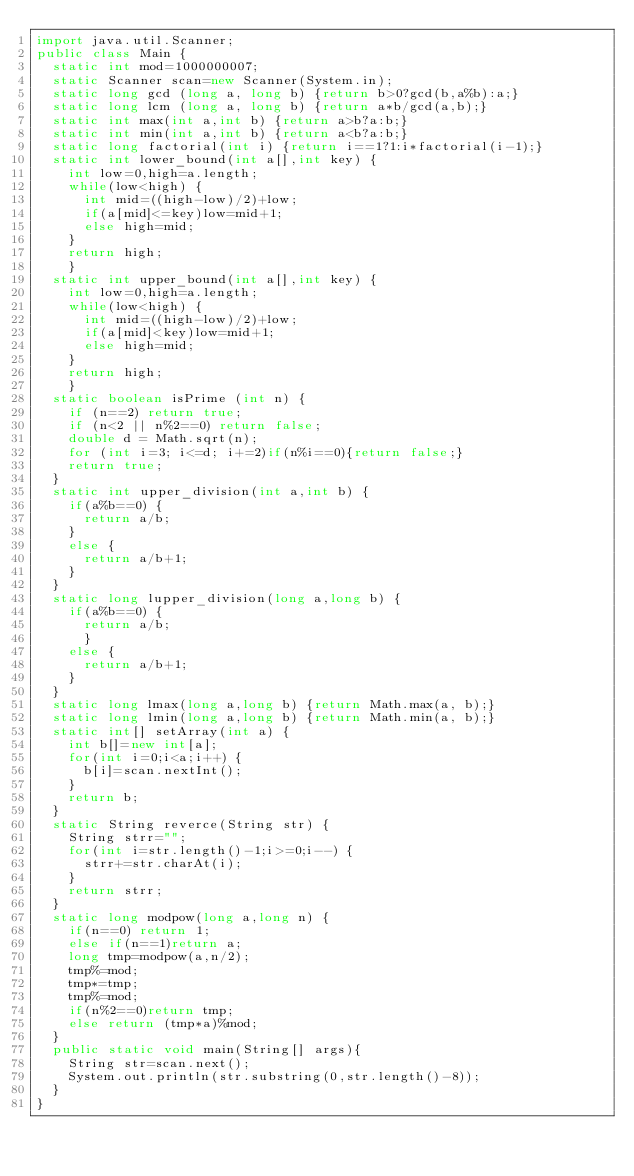Convert code to text. <code><loc_0><loc_0><loc_500><loc_500><_Java_>import java.util.Scanner;
public class Main {
	static int mod=1000000007;
	static Scanner scan=new Scanner(System.in);
	static long gcd (long a, long b) {return b>0?gcd(b,a%b):a;}
	static long lcm (long a, long b) {return a*b/gcd(a,b);}
	static int max(int a,int b) {return a>b?a:b;}
	static int min(int a,int b) {return a<b?a:b;}
	static long factorial(int i) {return i==1?1:i*factorial(i-1);}
	static int lower_bound(int a[],int key) {
		int low=0,high=a.length;
		while(low<high) {
			int mid=((high-low)/2)+low;
			if(a[mid]<=key)low=mid+1;
			else high=mid;
		}
		return high;
		}
	static int upper_bound(int a[],int key) {
		int low=0,high=a.length;
		while(low<high) {
			int mid=((high-low)/2)+low;
			if(a[mid]<key)low=mid+1;
			else high=mid;
		}
		return high;
		}
	static boolean isPrime (int n) {
		if (n==2) return true;
		if (n<2 || n%2==0) return false;
		double d = Math.sqrt(n);
		for (int i=3; i<=d; i+=2)if(n%i==0){return false;}
		return true;
	}
	static int upper_division(int a,int b) {
		if(a%b==0) {
			return a/b;
		}
		else {
			return a/b+1;
		}
	}
	static long lupper_division(long a,long b) {
		if(a%b==0) {
			return a/b;
			}
		else {
			return a/b+1;
		}
	}
	static long lmax(long a,long b) {return Math.max(a, b);}
	static long lmin(long a,long b) {return Math.min(a, b);}
	static int[] setArray(int a) {
		int b[]=new int[a];
		for(int i=0;i<a;i++) {
			b[i]=scan.nextInt();
		}
		return b;
	}
	static String reverce(String str) {
		String strr="";
		for(int i=str.length()-1;i>=0;i--) {
			strr+=str.charAt(i);
		}
		return strr;
	}
	static long modpow(long a,long n) {
		if(n==0) return 1;
		else if(n==1)return a;
		long tmp=modpow(a,n/2);
		tmp%=mod;
		tmp*=tmp;
		tmp%=mod;
		if(n%2==0)return tmp;
		else return (tmp*a)%mod;
	}
	public static void main(String[] args){
		String str=scan.next();
		System.out.println(str.substring(0,str.length()-8));
	}
}
</code> 